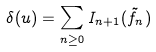<formula> <loc_0><loc_0><loc_500><loc_500>\delta ( u ) = \sum _ { n \geq 0 } I _ { n + 1 } ( \tilde { f } _ { n } )</formula> 